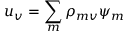<formula> <loc_0><loc_0><loc_500><loc_500>u _ { v } = \sum _ { m } \rho _ { m v } \psi _ { m }</formula> 